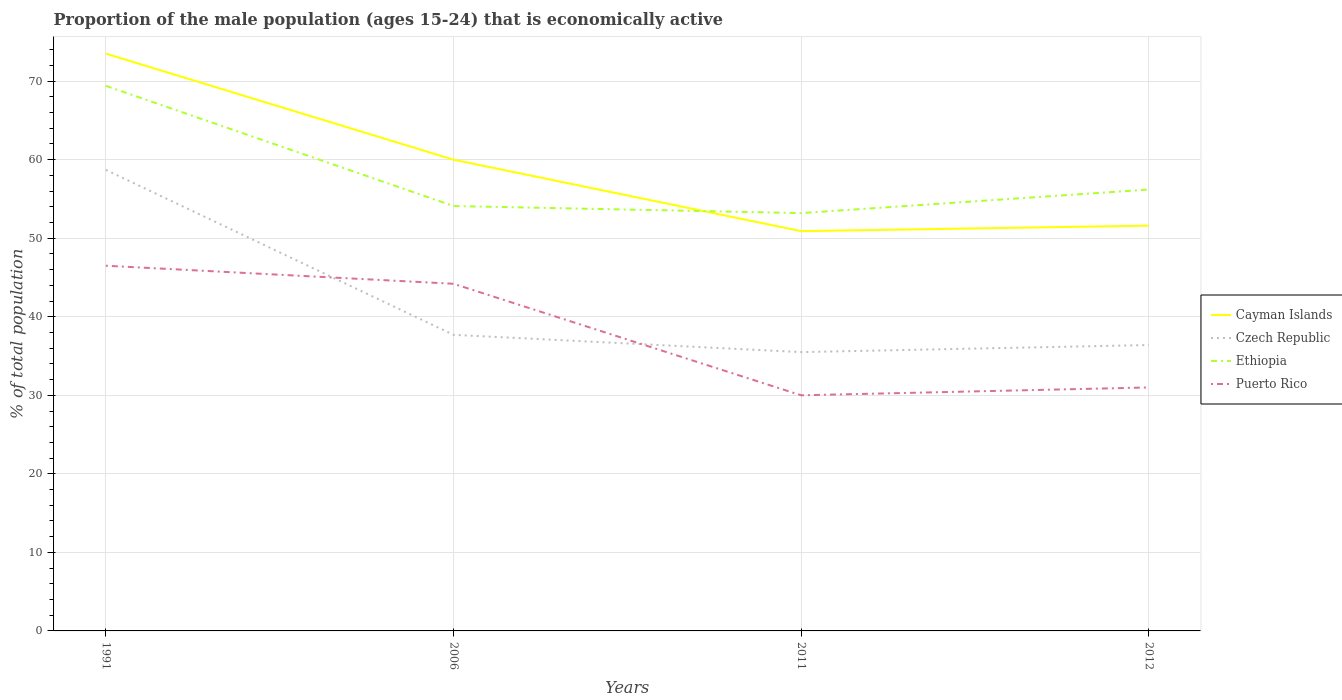Does the line corresponding to Ethiopia intersect with the line corresponding to Czech Republic?
Offer a very short reply. No. Across all years, what is the maximum proportion of the male population that is economically active in Czech Republic?
Make the answer very short. 35.5. In which year was the proportion of the male population that is economically active in Puerto Rico maximum?
Provide a succinct answer. 2011. What is the total proportion of the male population that is economically active in Puerto Rico in the graph?
Your answer should be very brief. -1. What is the difference between the highest and the second highest proportion of the male population that is economically active in Cayman Islands?
Keep it short and to the point. 22.6. Is the proportion of the male population that is economically active in Czech Republic strictly greater than the proportion of the male population that is economically active in Puerto Rico over the years?
Ensure brevity in your answer.  No. How many lines are there?
Your answer should be compact. 4. How many years are there in the graph?
Provide a short and direct response. 4. Does the graph contain any zero values?
Make the answer very short. No. Where does the legend appear in the graph?
Provide a short and direct response. Center right. How many legend labels are there?
Keep it short and to the point. 4. What is the title of the graph?
Your answer should be compact. Proportion of the male population (ages 15-24) that is economically active. What is the label or title of the X-axis?
Offer a very short reply. Years. What is the label or title of the Y-axis?
Make the answer very short. % of total population. What is the % of total population in Cayman Islands in 1991?
Ensure brevity in your answer.  73.5. What is the % of total population of Czech Republic in 1991?
Keep it short and to the point. 58.7. What is the % of total population in Ethiopia in 1991?
Offer a very short reply. 69.4. What is the % of total population of Puerto Rico in 1991?
Offer a terse response. 46.5. What is the % of total population in Cayman Islands in 2006?
Ensure brevity in your answer.  60. What is the % of total population in Czech Republic in 2006?
Provide a succinct answer. 37.7. What is the % of total population in Ethiopia in 2006?
Offer a terse response. 54.1. What is the % of total population of Puerto Rico in 2006?
Provide a succinct answer. 44.2. What is the % of total population in Cayman Islands in 2011?
Make the answer very short. 50.9. What is the % of total population in Czech Republic in 2011?
Ensure brevity in your answer.  35.5. What is the % of total population of Ethiopia in 2011?
Give a very brief answer. 53.2. What is the % of total population of Puerto Rico in 2011?
Make the answer very short. 30. What is the % of total population in Cayman Islands in 2012?
Keep it short and to the point. 51.6. What is the % of total population of Czech Republic in 2012?
Keep it short and to the point. 36.4. What is the % of total population of Ethiopia in 2012?
Your response must be concise. 56.2. What is the % of total population of Puerto Rico in 2012?
Ensure brevity in your answer.  31. Across all years, what is the maximum % of total population of Cayman Islands?
Provide a succinct answer. 73.5. Across all years, what is the maximum % of total population of Czech Republic?
Ensure brevity in your answer.  58.7. Across all years, what is the maximum % of total population of Ethiopia?
Make the answer very short. 69.4. Across all years, what is the maximum % of total population in Puerto Rico?
Keep it short and to the point. 46.5. Across all years, what is the minimum % of total population of Cayman Islands?
Your answer should be compact. 50.9. Across all years, what is the minimum % of total population in Czech Republic?
Your answer should be compact. 35.5. Across all years, what is the minimum % of total population in Ethiopia?
Offer a terse response. 53.2. Across all years, what is the minimum % of total population in Puerto Rico?
Offer a terse response. 30. What is the total % of total population in Cayman Islands in the graph?
Ensure brevity in your answer.  236. What is the total % of total population in Czech Republic in the graph?
Keep it short and to the point. 168.3. What is the total % of total population of Ethiopia in the graph?
Your answer should be very brief. 232.9. What is the total % of total population in Puerto Rico in the graph?
Ensure brevity in your answer.  151.7. What is the difference between the % of total population of Ethiopia in 1991 and that in 2006?
Your answer should be very brief. 15.3. What is the difference between the % of total population in Puerto Rico in 1991 and that in 2006?
Keep it short and to the point. 2.3. What is the difference between the % of total population in Cayman Islands in 1991 and that in 2011?
Give a very brief answer. 22.6. What is the difference between the % of total population of Czech Republic in 1991 and that in 2011?
Offer a terse response. 23.2. What is the difference between the % of total population in Puerto Rico in 1991 and that in 2011?
Your answer should be very brief. 16.5. What is the difference between the % of total population of Cayman Islands in 1991 and that in 2012?
Offer a very short reply. 21.9. What is the difference between the % of total population of Czech Republic in 1991 and that in 2012?
Provide a succinct answer. 22.3. What is the difference between the % of total population of Cayman Islands in 2006 and that in 2011?
Provide a short and direct response. 9.1. What is the difference between the % of total population of Puerto Rico in 2006 and that in 2011?
Provide a succinct answer. 14.2. What is the difference between the % of total population of Cayman Islands in 2006 and that in 2012?
Your response must be concise. 8.4. What is the difference between the % of total population of Czech Republic in 2006 and that in 2012?
Your answer should be compact. 1.3. What is the difference between the % of total population in Ethiopia in 2006 and that in 2012?
Provide a short and direct response. -2.1. What is the difference between the % of total population of Puerto Rico in 2006 and that in 2012?
Make the answer very short. 13.2. What is the difference between the % of total population of Cayman Islands in 2011 and that in 2012?
Make the answer very short. -0.7. What is the difference between the % of total population in Czech Republic in 2011 and that in 2012?
Provide a succinct answer. -0.9. What is the difference between the % of total population in Ethiopia in 2011 and that in 2012?
Offer a terse response. -3. What is the difference between the % of total population in Puerto Rico in 2011 and that in 2012?
Provide a short and direct response. -1. What is the difference between the % of total population in Cayman Islands in 1991 and the % of total population in Czech Republic in 2006?
Your response must be concise. 35.8. What is the difference between the % of total population of Cayman Islands in 1991 and the % of total population of Ethiopia in 2006?
Your response must be concise. 19.4. What is the difference between the % of total population in Cayman Islands in 1991 and the % of total population in Puerto Rico in 2006?
Provide a succinct answer. 29.3. What is the difference between the % of total population of Ethiopia in 1991 and the % of total population of Puerto Rico in 2006?
Your response must be concise. 25.2. What is the difference between the % of total population of Cayman Islands in 1991 and the % of total population of Czech Republic in 2011?
Provide a succinct answer. 38. What is the difference between the % of total population of Cayman Islands in 1991 and the % of total population of Ethiopia in 2011?
Your answer should be very brief. 20.3. What is the difference between the % of total population in Cayman Islands in 1991 and the % of total population in Puerto Rico in 2011?
Offer a terse response. 43.5. What is the difference between the % of total population of Czech Republic in 1991 and the % of total population of Ethiopia in 2011?
Your answer should be very brief. 5.5. What is the difference between the % of total population in Czech Republic in 1991 and the % of total population in Puerto Rico in 2011?
Provide a succinct answer. 28.7. What is the difference between the % of total population of Ethiopia in 1991 and the % of total population of Puerto Rico in 2011?
Provide a succinct answer. 39.4. What is the difference between the % of total population in Cayman Islands in 1991 and the % of total population in Czech Republic in 2012?
Offer a terse response. 37.1. What is the difference between the % of total population in Cayman Islands in 1991 and the % of total population in Puerto Rico in 2012?
Your answer should be very brief. 42.5. What is the difference between the % of total population in Czech Republic in 1991 and the % of total population in Ethiopia in 2012?
Keep it short and to the point. 2.5. What is the difference between the % of total population in Czech Republic in 1991 and the % of total population in Puerto Rico in 2012?
Your answer should be compact. 27.7. What is the difference between the % of total population of Ethiopia in 1991 and the % of total population of Puerto Rico in 2012?
Your answer should be compact. 38.4. What is the difference between the % of total population of Cayman Islands in 2006 and the % of total population of Czech Republic in 2011?
Provide a short and direct response. 24.5. What is the difference between the % of total population in Cayman Islands in 2006 and the % of total population in Ethiopia in 2011?
Offer a very short reply. 6.8. What is the difference between the % of total population of Cayman Islands in 2006 and the % of total population of Puerto Rico in 2011?
Ensure brevity in your answer.  30. What is the difference between the % of total population in Czech Republic in 2006 and the % of total population in Ethiopia in 2011?
Make the answer very short. -15.5. What is the difference between the % of total population of Ethiopia in 2006 and the % of total population of Puerto Rico in 2011?
Offer a terse response. 24.1. What is the difference between the % of total population of Cayman Islands in 2006 and the % of total population of Czech Republic in 2012?
Offer a terse response. 23.6. What is the difference between the % of total population in Cayman Islands in 2006 and the % of total population in Puerto Rico in 2012?
Ensure brevity in your answer.  29. What is the difference between the % of total population of Czech Republic in 2006 and the % of total population of Ethiopia in 2012?
Your answer should be very brief. -18.5. What is the difference between the % of total population of Ethiopia in 2006 and the % of total population of Puerto Rico in 2012?
Keep it short and to the point. 23.1. What is the difference between the % of total population of Cayman Islands in 2011 and the % of total population of Czech Republic in 2012?
Your answer should be compact. 14.5. What is the difference between the % of total population in Cayman Islands in 2011 and the % of total population in Ethiopia in 2012?
Provide a short and direct response. -5.3. What is the difference between the % of total population of Czech Republic in 2011 and the % of total population of Ethiopia in 2012?
Give a very brief answer. -20.7. What is the difference between the % of total population of Ethiopia in 2011 and the % of total population of Puerto Rico in 2012?
Keep it short and to the point. 22.2. What is the average % of total population in Czech Republic per year?
Your answer should be compact. 42.08. What is the average % of total population of Ethiopia per year?
Give a very brief answer. 58.23. What is the average % of total population in Puerto Rico per year?
Give a very brief answer. 37.92. In the year 1991, what is the difference between the % of total population of Cayman Islands and % of total population of Czech Republic?
Your answer should be very brief. 14.8. In the year 1991, what is the difference between the % of total population of Cayman Islands and % of total population of Ethiopia?
Offer a very short reply. 4.1. In the year 1991, what is the difference between the % of total population in Cayman Islands and % of total population in Puerto Rico?
Offer a very short reply. 27. In the year 1991, what is the difference between the % of total population of Czech Republic and % of total population of Ethiopia?
Make the answer very short. -10.7. In the year 1991, what is the difference between the % of total population in Ethiopia and % of total population in Puerto Rico?
Your answer should be compact. 22.9. In the year 2006, what is the difference between the % of total population of Cayman Islands and % of total population of Czech Republic?
Keep it short and to the point. 22.3. In the year 2006, what is the difference between the % of total population in Cayman Islands and % of total population in Puerto Rico?
Make the answer very short. 15.8. In the year 2006, what is the difference between the % of total population in Czech Republic and % of total population in Ethiopia?
Provide a short and direct response. -16.4. In the year 2006, what is the difference between the % of total population in Ethiopia and % of total population in Puerto Rico?
Provide a succinct answer. 9.9. In the year 2011, what is the difference between the % of total population of Cayman Islands and % of total population of Ethiopia?
Make the answer very short. -2.3. In the year 2011, what is the difference between the % of total population in Cayman Islands and % of total population in Puerto Rico?
Offer a very short reply. 20.9. In the year 2011, what is the difference between the % of total population in Czech Republic and % of total population in Ethiopia?
Make the answer very short. -17.7. In the year 2011, what is the difference between the % of total population of Ethiopia and % of total population of Puerto Rico?
Your response must be concise. 23.2. In the year 2012, what is the difference between the % of total population in Cayman Islands and % of total population in Czech Republic?
Your answer should be compact. 15.2. In the year 2012, what is the difference between the % of total population in Cayman Islands and % of total population in Puerto Rico?
Your answer should be compact. 20.6. In the year 2012, what is the difference between the % of total population of Czech Republic and % of total population of Ethiopia?
Give a very brief answer. -19.8. In the year 2012, what is the difference between the % of total population in Czech Republic and % of total population in Puerto Rico?
Offer a terse response. 5.4. In the year 2012, what is the difference between the % of total population of Ethiopia and % of total population of Puerto Rico?
Offer a very short reply. 25.2. What is the ratio of the % of total population of Cayman Islands in 1991 to that in 2006?
Give a very brief answer. 1.23. What is the ratio of the % of total population of Czech Republic in 1991 to that in 2006?
Keep it short and to the point. 1.56. What is the ratio of the % of total population in Ethiopia in 1991 to that in 2006?
Make the answer very short. 1.28. What is the ratio of the % of total population of Puerto Rico in 1991 to that in 2006?
Keep it short and to the point. 1.05. What is the ratio of the % of total population in Cayman Islands in 1991 to that in 2011?
Make the answer very short. 1.44. What is the ratio of the % of total population in Czech Republic in 1991 to that in 2011?
Keep it short and to the point. 1.65. What is the ratio of the % of total population of Ethiopia in 1991 to that in 2011?
Provide a succinct answer. 1.3. What is the ratio of the % of total population of Puerto Rico in 1991 to that in 2011?
Ensure brevity in your answer.  1.55. What is the ratio of the % of total population of Cayman Islands in 1991 to that in 2012?
Your answer should be very brief. 1.42. What is the ratio of the % of total population of Czech Republic in 1991 to that in 2012?
Your response must be concise. 1.61. What is the ratio of the % of total population in Ethiopia in 1991 to that in 2012?
Ensure brevity in your answer.  1.23. What is the ratio of the % of total population of Cayman Islands in 2006 to that in 2011?
Give a very brief answer. 1.18. What is the ratio of the % of total population of Czech Republic in 2006 to that in 2011?
Provide a succinct answer. 1.06. What is the ratio of the % of total population of Ethiopia in 2006 to that in 2011?
Give a very brief answer. 1.02. What is the ratio of the % of total population of Puerto Rico in 2006 to that in 2011?
Your answer should be very brief. 1.47. What is the ratio of the % of total population in Cayman Islands in 2006 to that in 2012?
Your response must be concise. 1.16. What is the ratio of the % of total population of Czech Republic in 2006 to that in 2012?
Offer a very short reply. 1.04. What is the ratio of the % of total population in Ethiopia in 2006 to that in 2012?
Offer a terse response. 0.96. What is the ratio of the % of total population in Puerto Rico in 2006 to that in 2012?
Keep it short and to the point. 1.43. What is the ratio of the % of total population of Cayman Islands in 2011 to that in 2012?
Ensure brevity in your answer.  0.99. What is the ratio of the % of total population in Czech Republic in 2011 to that in 2012?
Your answer should be very brief. 0.98. What is the ratio of the % of total population in Ethiopia in 2011 to that in 2012?
Offer a terse response. 0.95. What is the ratio of the % of total population in Puerto Rico in 2011 to that in 2012?
Your answer should be compact. 0.97. What is the difference between the highest and the second highest % of total population in Cayman Islands?
Offer a terse response. 13.5. What is the difference between the highest and the second highest % of total population of Czech Republic?
Make the answer very short. 21. What is the difference between the highest and the second highest % of total population of Ethiopia?
Your response must be concise. 13.2. What is the difference between the highest and the second highest % of total population in Puerto Rico?
Provide a succinct answer. 2.3. What is the difference between the highest and the lowest % of total population of Cayman Islands?
Your answer should be very brief. 22.6. What is the difference between the highest and the lowest % of total population in Czech Republic?
Make the answer very short. 23.2. What is the difference between the highest and the lowest % of total population of Ethiopia?
Your answer should be compact. 16.2. 